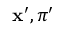<formula> <loc_0><loc_0><loc_500><loc_500>x ^ { \prime } , \pi ^ { \prime }</formula> 